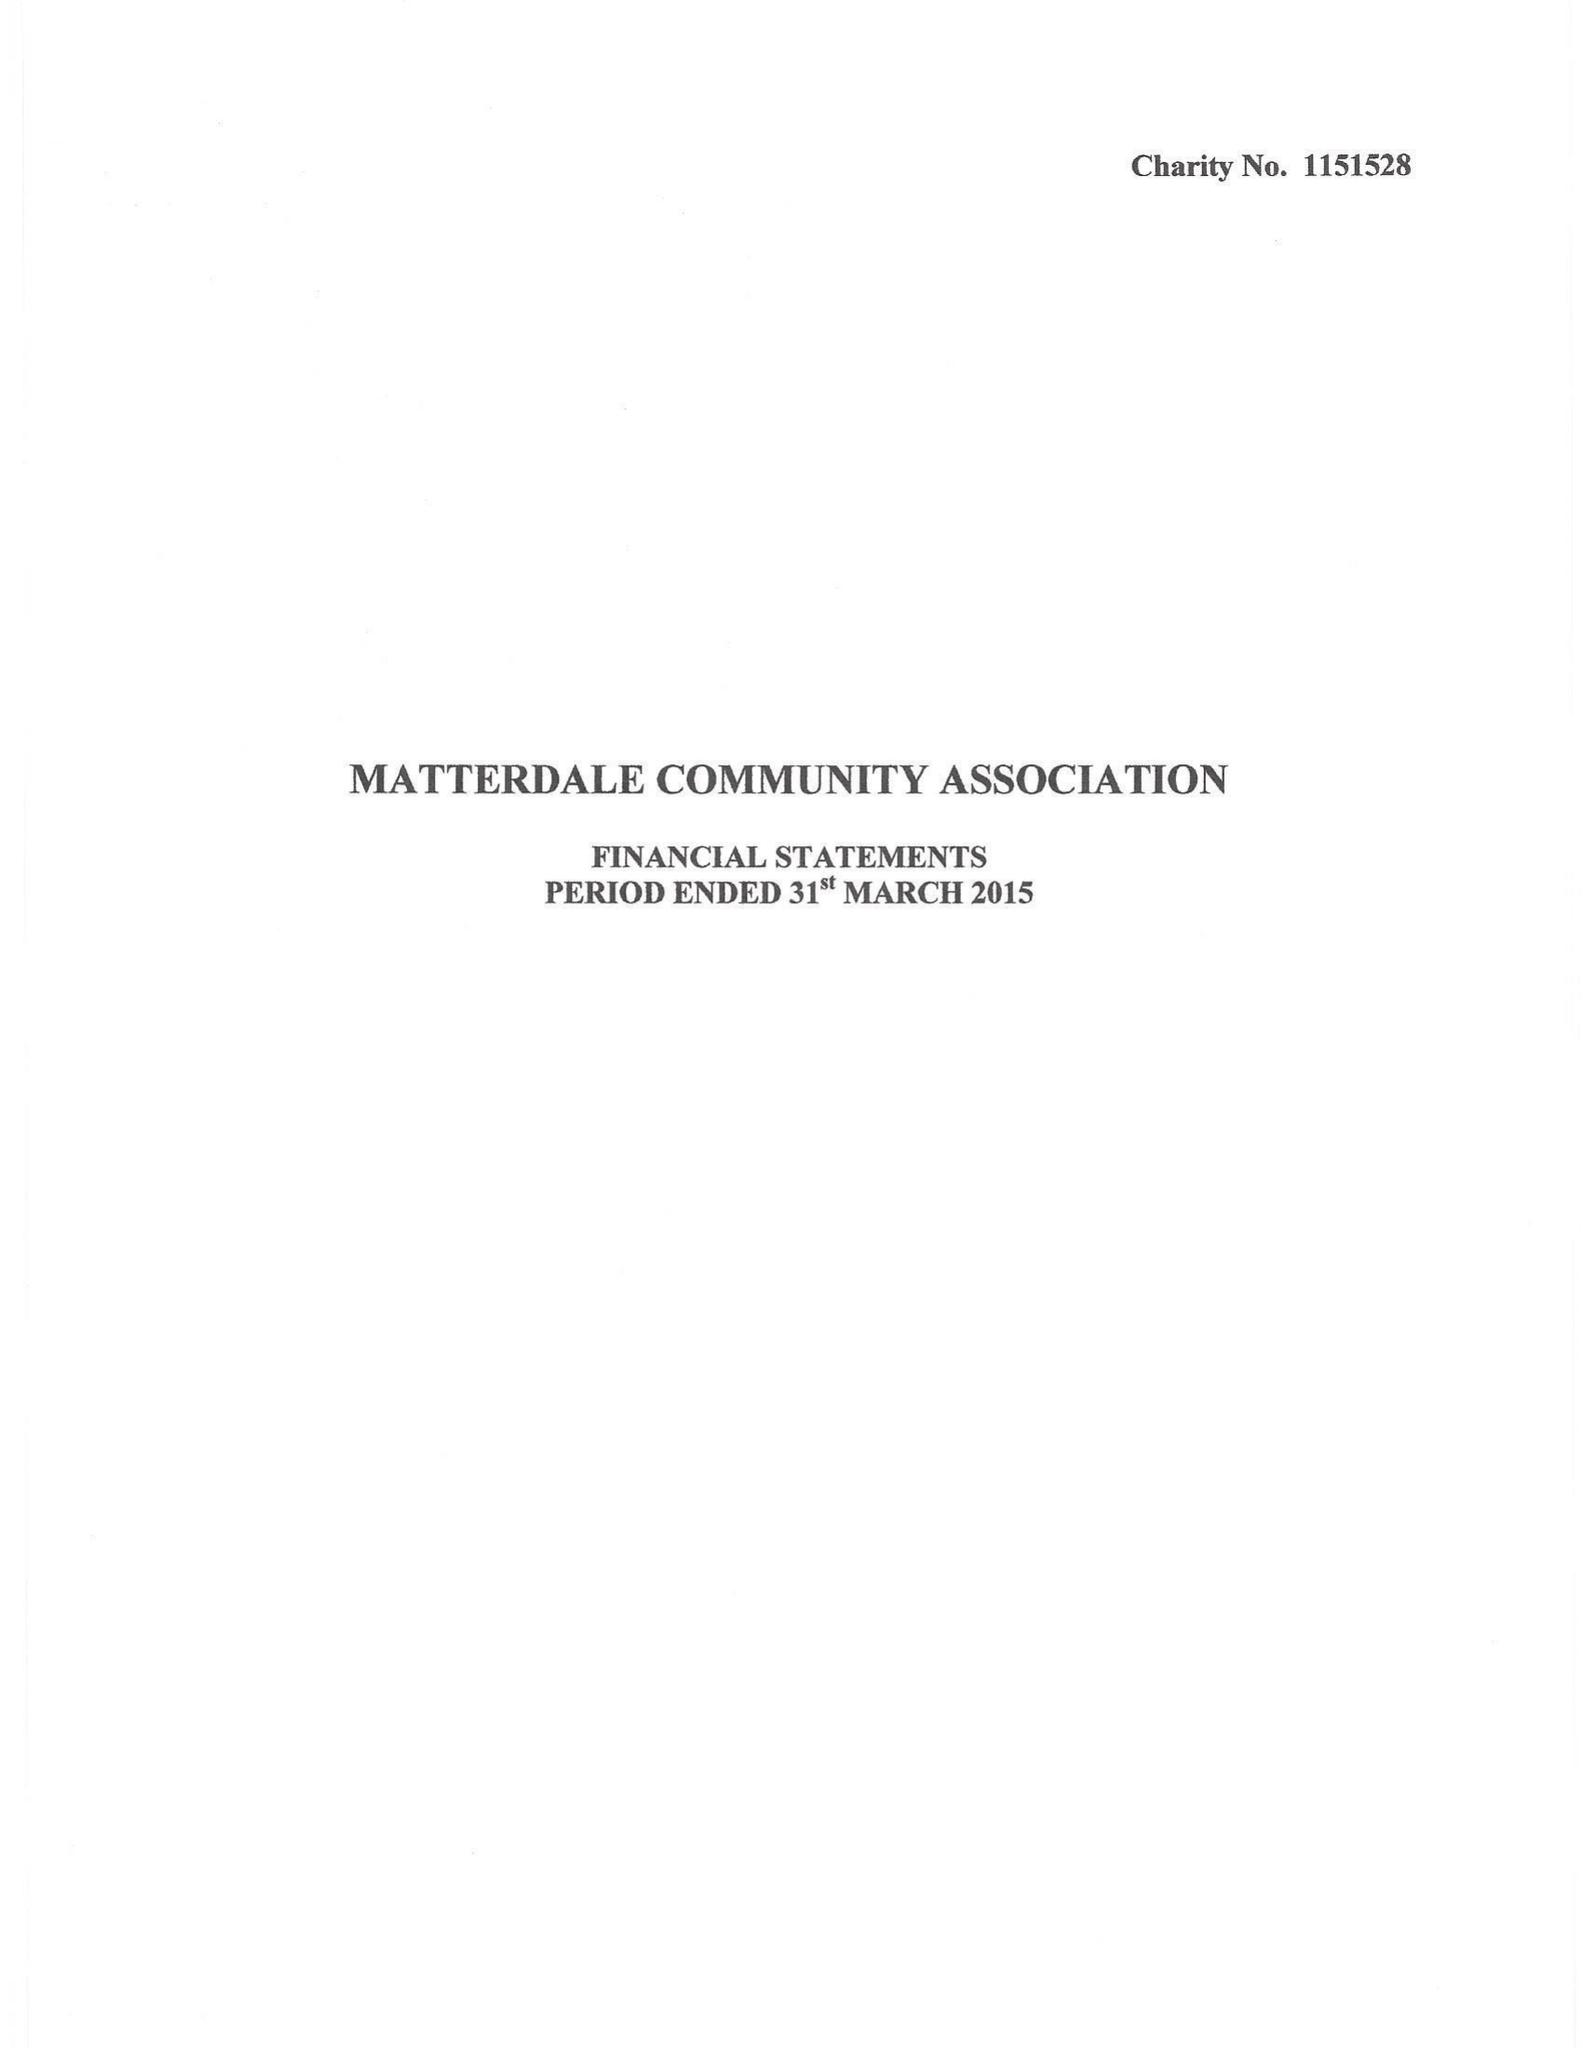What is the value for the charity_name?
Answer the question using a single word or phrase. Matterdale Community Association 